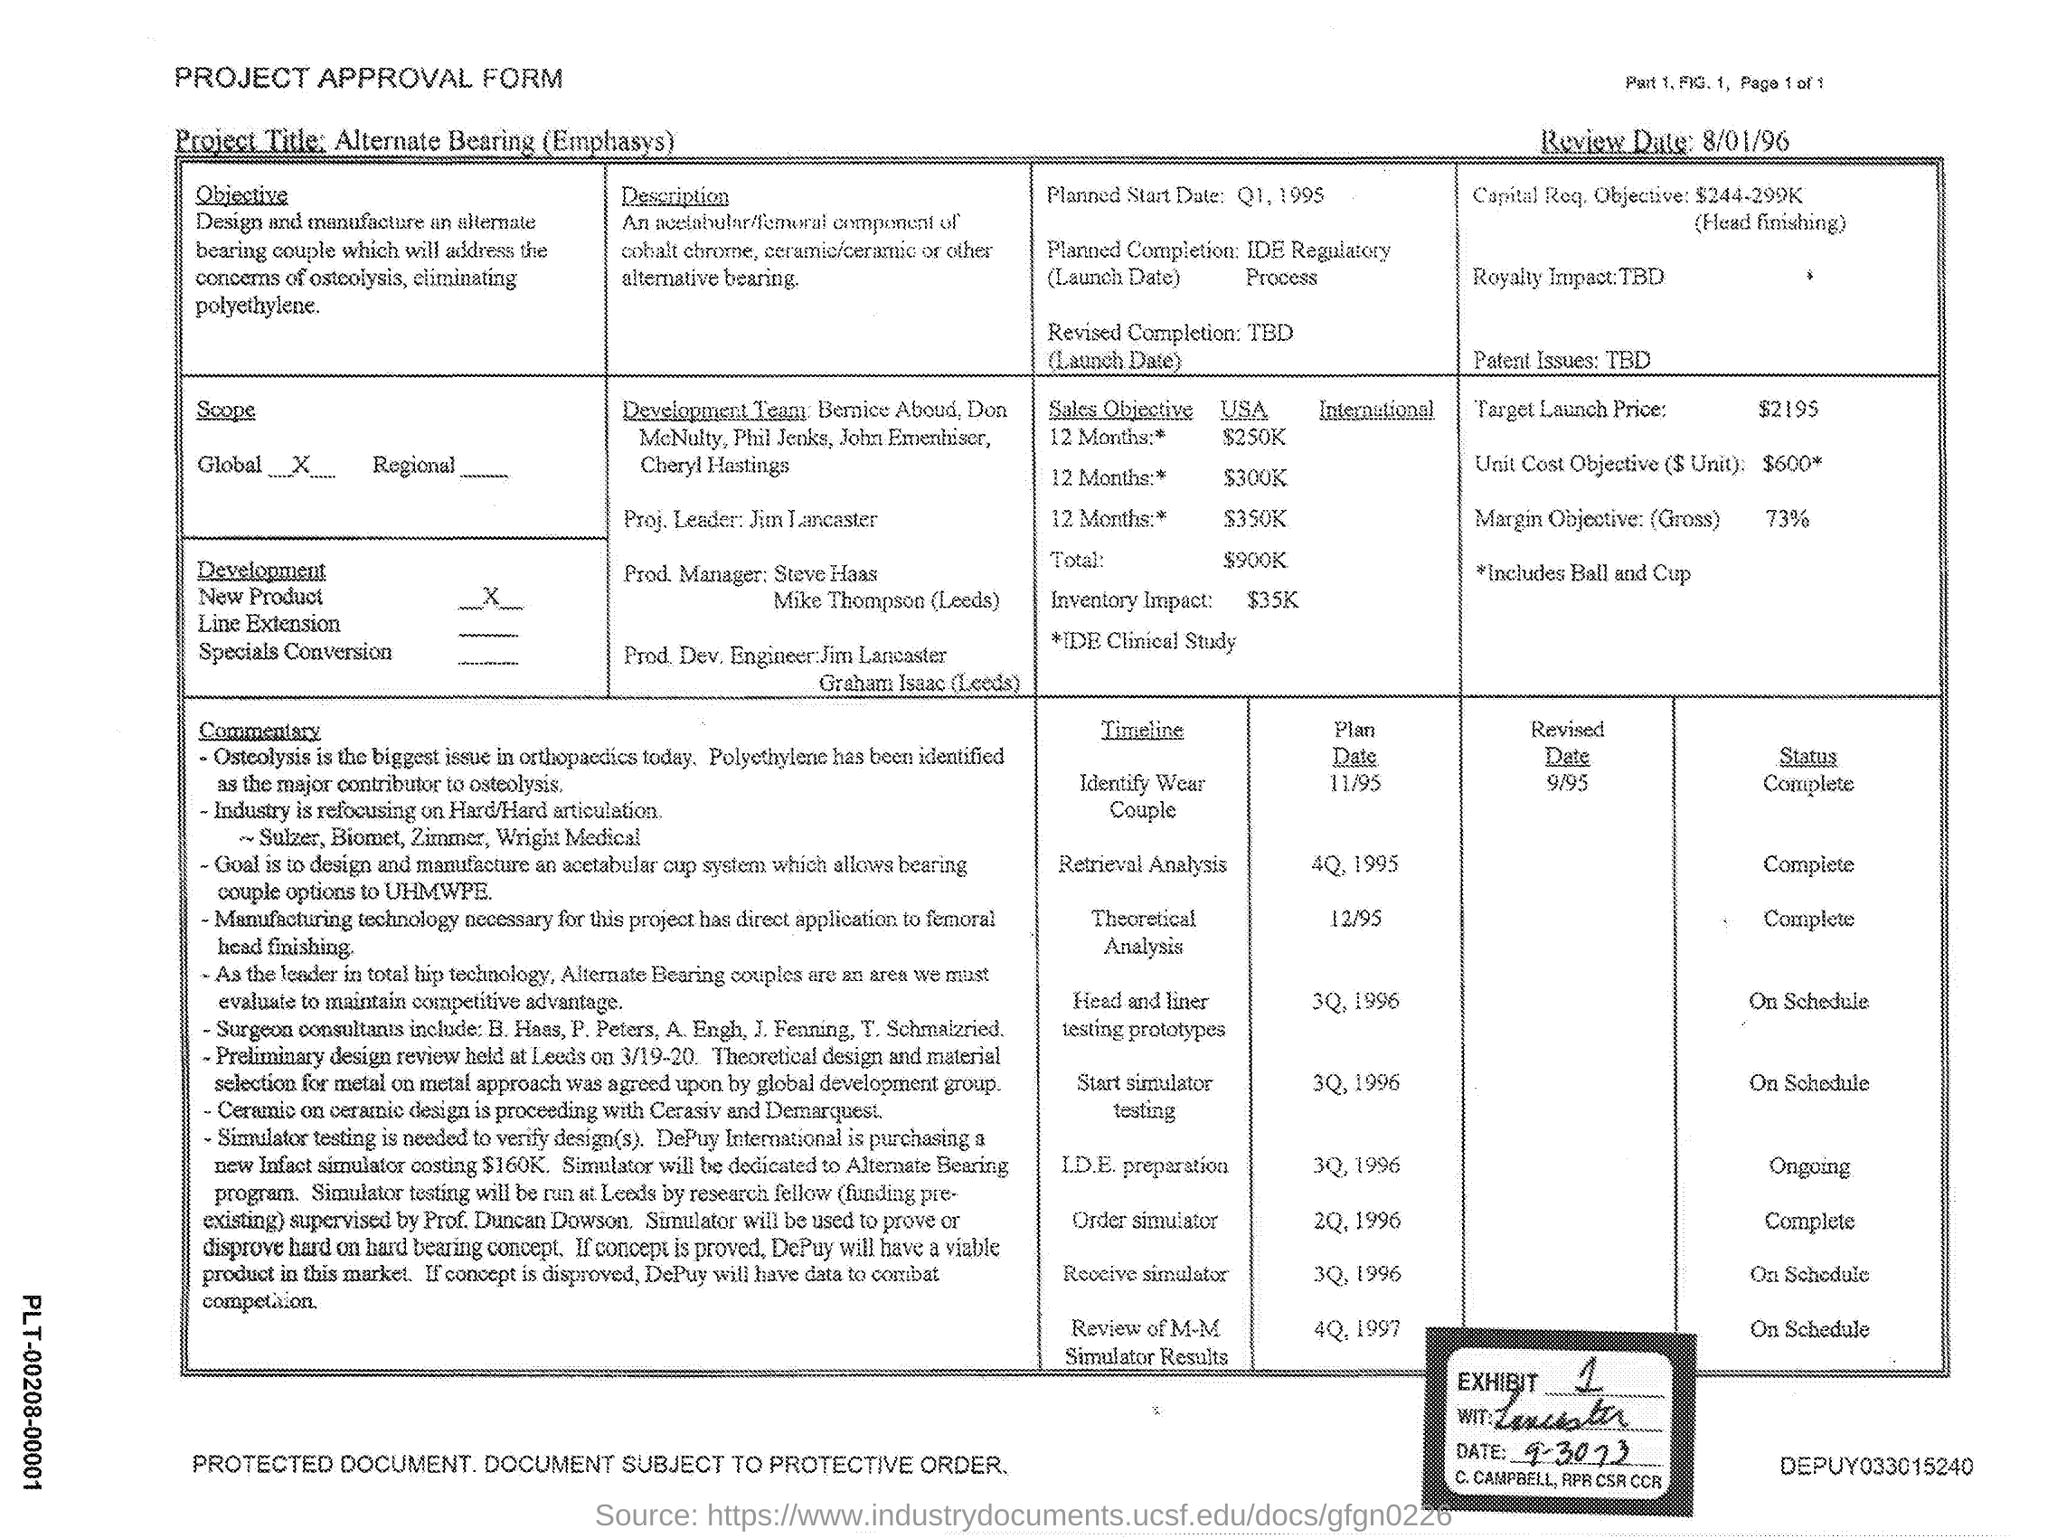What type of form is this?
Ensure brevity in your answer.  PROJECT APPROVAL FORM. What is the review date mentioned in the form?
Make the answer very short. 8/01/96. What is the target launch price mentioned in the form?
Ensure brevity in your answer.  2195. What is the scope of the project?
Provide a succinct answer. Global. Who is the Proj. Leader of the Development team?
Your answer should be compact. Jim Lancaster. 